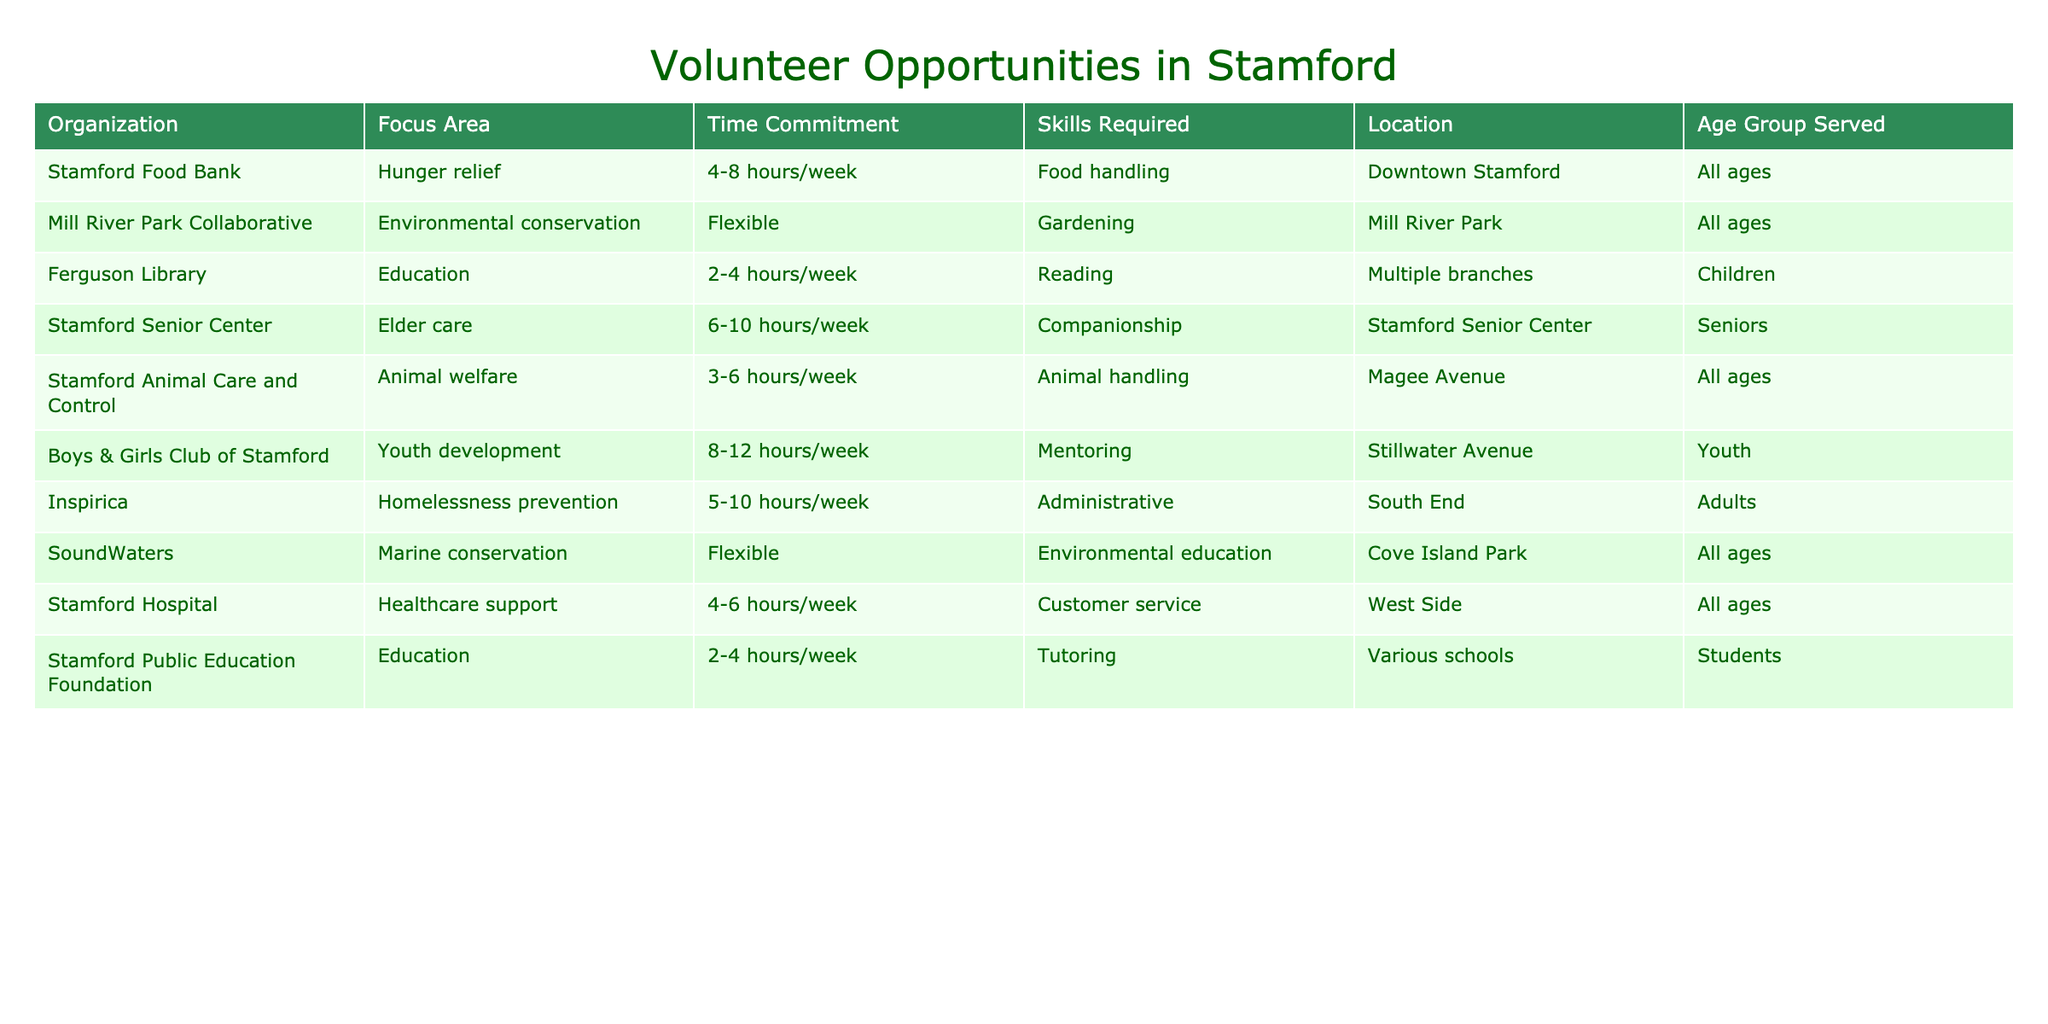What is the focus area of Stamford Animal Care and Control? Stamford Animal Care and Control focuses on animal welfare, as indicated in the table under the "Focus Area" column.
Answer: Animal welfare How many hours per week does a volunteer need to commit to work at the Ferguson Library? The Ferguson Library requires a time commitment of 2-4 hours per week, as shown in the "Time Commitment" column.
Answer: 2-4 hours/week Which two organizations provide volunteer opportunities that serve all ages? By checking the "Age Group Served" column, Stamford Food Bank and Stamford Animal Care and Control both serve all ages.
Answer: Stamford Food Bank, Stamford Animal Care and Control Are the skills required for volunteering at the Stamford Senior Center compatible with those needed at the Boys & Girls Club of Stamford? The Stamford Senior Center requires skills in companionship, while the Boys & Girls Club of Stamford requires mentoring skills. Since these skills are different, they are not compatible.
Answer: No What is the total time commitment range of the organizations focused on education? The Ferguson Library has a commitment of 2-4 hours/week, and the Stamford Public Education Foundation also has 2-4 hours/week, while the Boys & Girls Club of Stamford requires 8-12 hours/week. The total range combining these commitments shows a span from 2 to 12 hours/week.
Answer: 2-12 hours/week How many organizations require administrative skills? Looking through the "Skills Required" column, only one organization, Inspirica, explicitly mentions administrative skills.
Answer: 1 Which organizations are located in Downtown Stamford? The only organization mentioned in Downtown Stamford is the Stamford Food Bank, which is listed in the "Location" column.
Answer: Stamford Food Bank What age group is served by the Mill River Park Collaborative? The table specifies that the Mill River Park Collaborative serves all ages, as indicated in the "Age Group Served" column.
Answer: All ages 